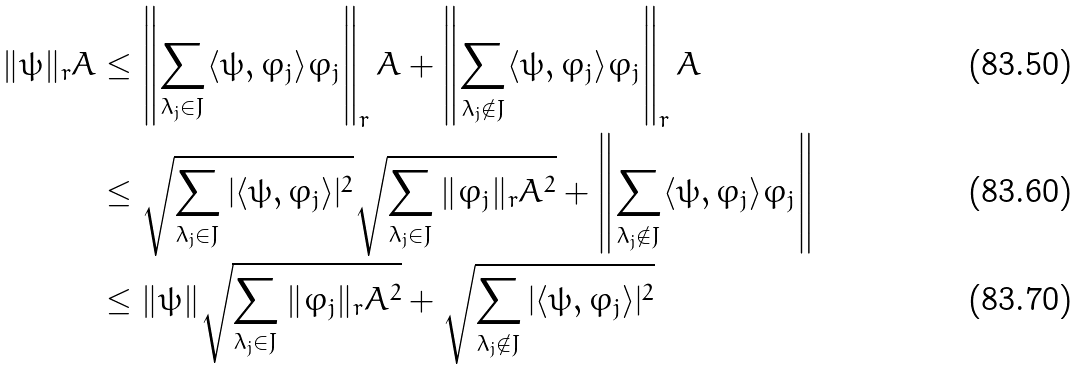<formula> <loc_0><loc_0><loc_500><loc_500>\| \psi \| _ { r } A & \leq \left \| \sum _ { \lambda _ { j } \in J } \langle \psi , \varphi _ { j } \rangle \varphi _ { j } \right \| _ { r } A + \left \| \sum _ { \lambda _ { j } \notin J } \langle \psi , \varphi _ { j } \rangle \varphi _ { j } \right \| _ { r } A \\ & \leq \sqrt { \sum _ { \lambda _ { j } \in J } | \langle \psi , \varphi _ { j } \rangle | ^ { 2 } } \sqrt { \sum _ { \lambda _ { j } \in J } \| \varphi _ { j } \| _ { r } A ^ { 2 } } + \left \| \sum _ { \lambda _ { j } \notin J } \langle \psi , \varphi _ { j } \rangle \varphi _ { j } \right \| \\ & \leq \| \psi \| \sqrt { \sum _ { \lambda _ { j } \in J } \| \varphi _ { j } \| _ { r } A ^ { 2 } } + \sqrt { \sum _ { \lambda _ { j } \notin J } | \langle \psi , \varphi _ { j } \rangle | ^ { 2 } }</formula> 